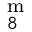<formula> <loc_0><loc_0><loc_500><loc_500>^ { m } _ { 8 }</formula> 